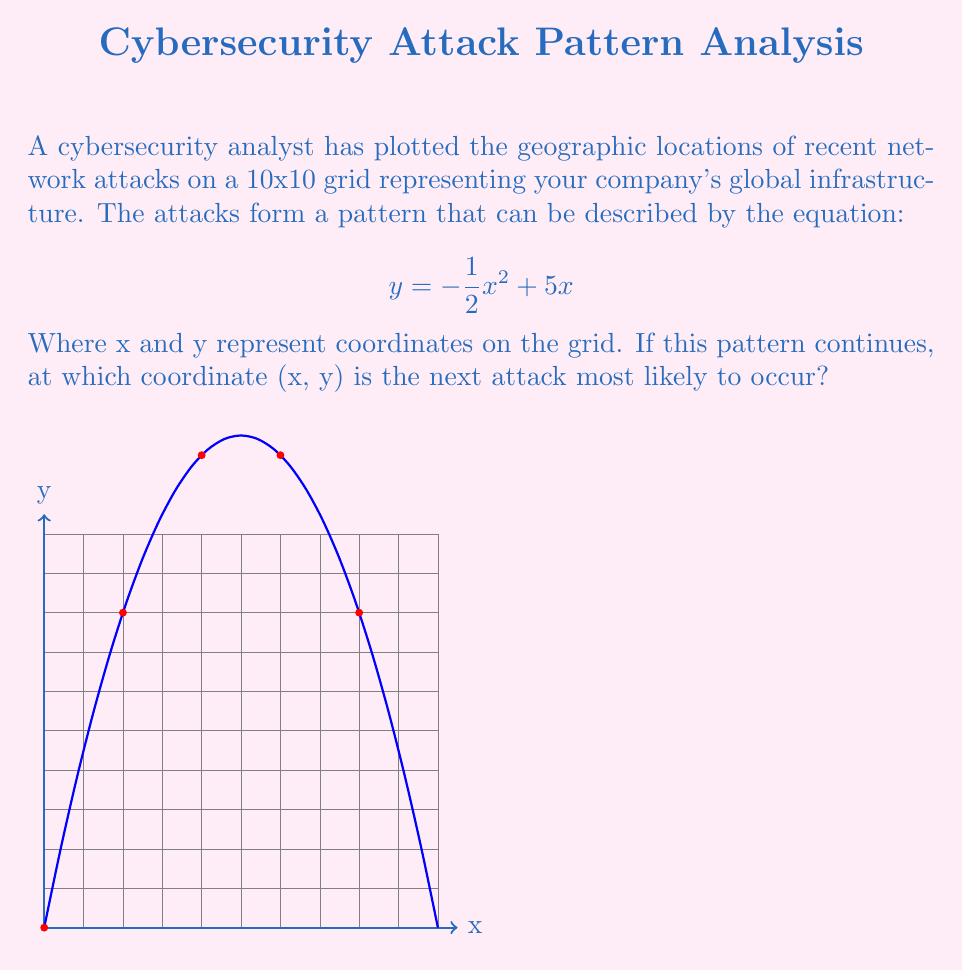Give your solution to this math problem. To solve this problem, we need to follow these steps:

1) The equation $y = -\frac{1}{2}x^2 + 5x$ represents a parabola. The attacks are occurring along this parabola.

2) To find the next likely attack point, we need to find the maximum point of this parabola, as it represents the highest point on the grid where an attack could occur.

3) To find the maximum point, we need to find the vertex of the parabola. For a quadratic equation in the form $y = ax^2 + bx + c$, the x-coordinate of the vertex is given by $x = -\frac{b}{2a}$.

4) In our equation, $a = -\frac{1}{2}$ and $b = 5$. So:

   $x = -\frac{5}{2(-\frac{1}{2})} = -\frac{5}{-1} = 5$

5) To find the y-coordinate, we substitute x = 5 into the original equation:

   $y = -\frac{1}{2}(5)^2 + 5(5) = -\frac{25}{2} + 25 = -12.5 + 25 = 12.5$

6) Therefore, the vertex of the parabola is at the point (5, 12.5).

7) However, since we're working on a grid with integer coordinates, we need to round this to the nearest whole number.

Thus, the next attack is most likely to occur at the coordinate (5, 13).
Answer: (5, 13) 